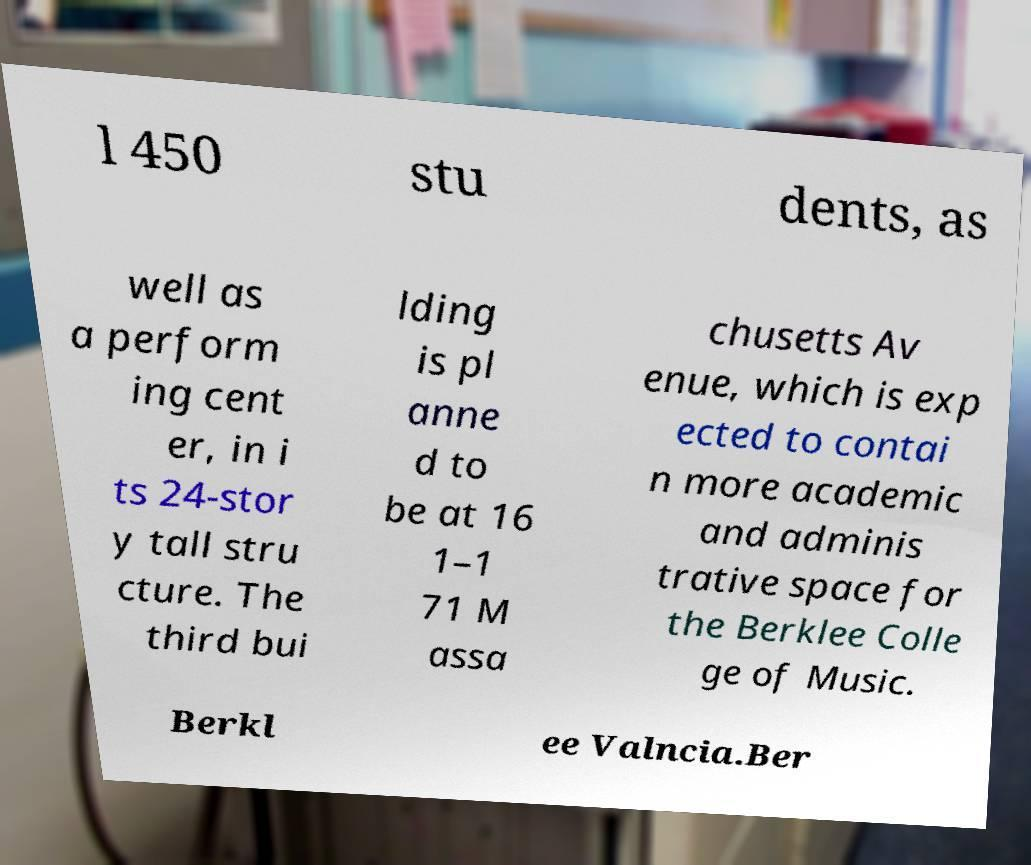Can you read and provide the text displayed in the image?This photo seems to have some interesting text. Can you extract and type it out for me? l 450 stu dents, as well as a perform ing cent er, in i ts 24-stor y tall stru cture. The third bui lding is pl anne d to be at 16 1–1 71 M assa chusetts Av enue, which is exp ected to contai n more academic and adminis trative space for the Berklee Colle ge of Music. Berkl ee Valncia.Ber 